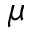Convert formula to latex. <formula><loc_0><loc_0><loc_500><loc_500>\mu</formula> 